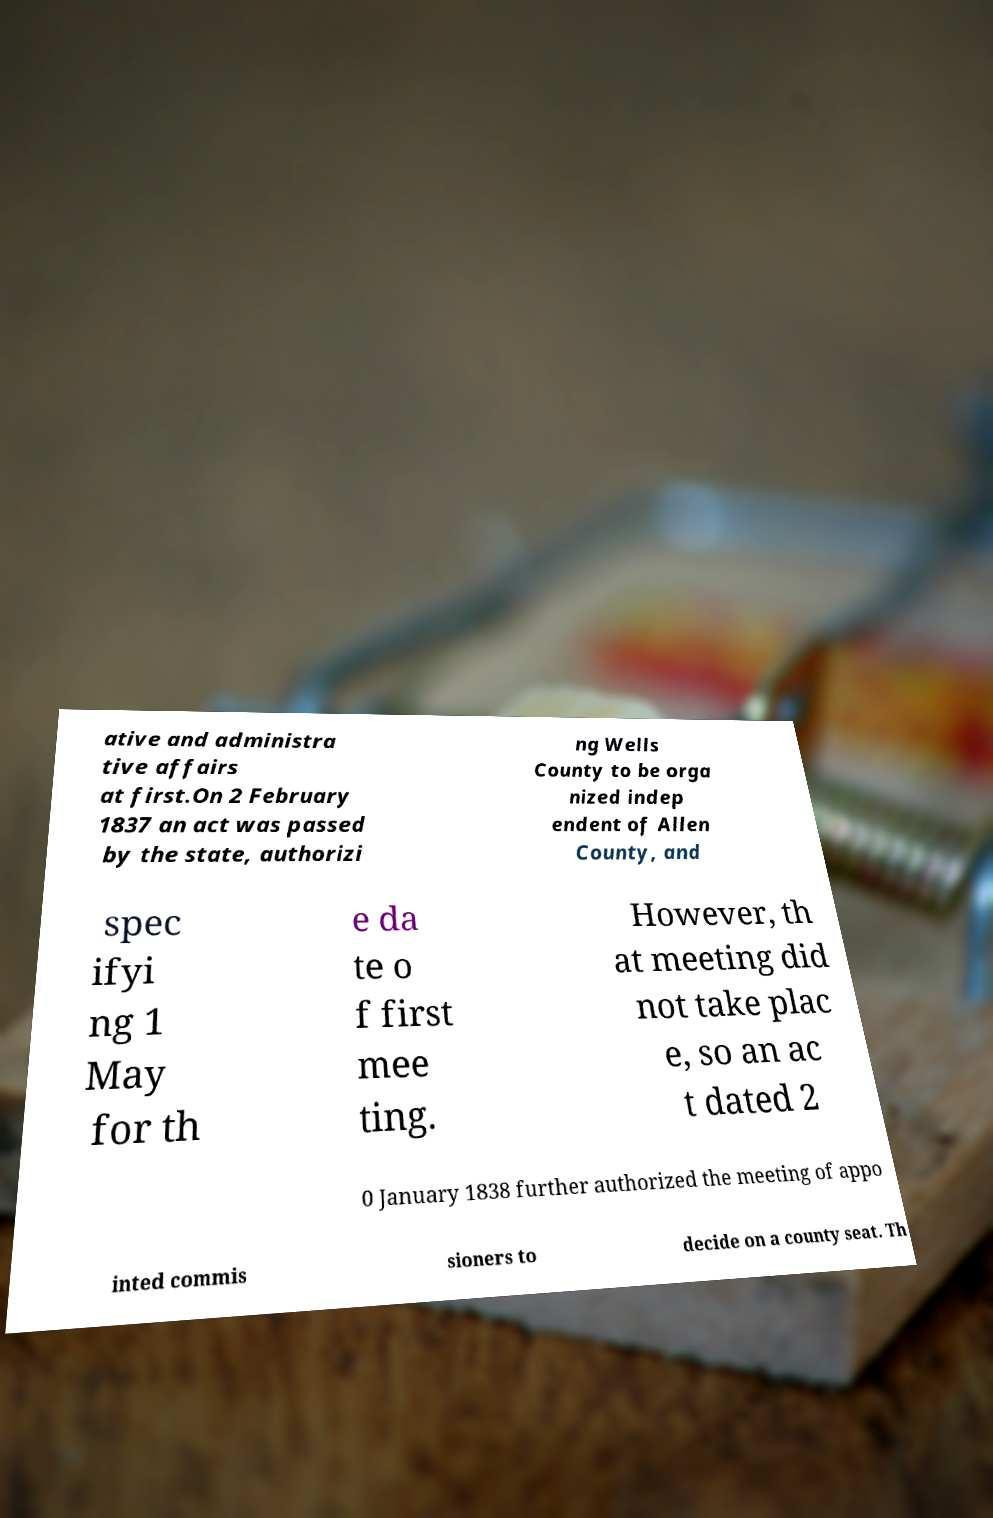There's text embedded in this image that I need extracted. Can you transcribe it verbatim? ative and administra tive affairs at first.On 2 February 1837 an act was passed by the state, authorizi ng Wells County to be orga nized indep endent of Allen County, and spec ifyi ng 1 May for th e da te o f first mee ting. However, th at meeting did not take plac e, so an ac t dated 2 0 January 1838 further authorized the meeting of appo inted commis sioners to decide on a county seat. Th 